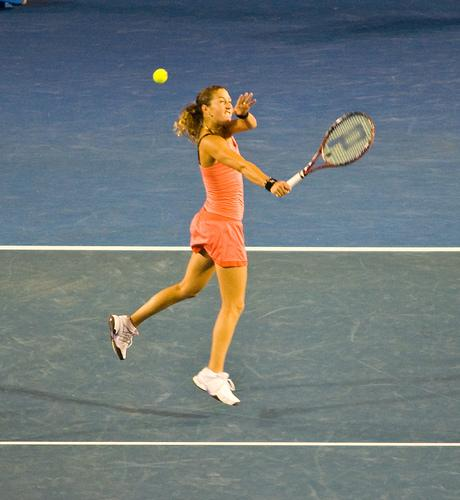Who supplied her tennis racket? prince 